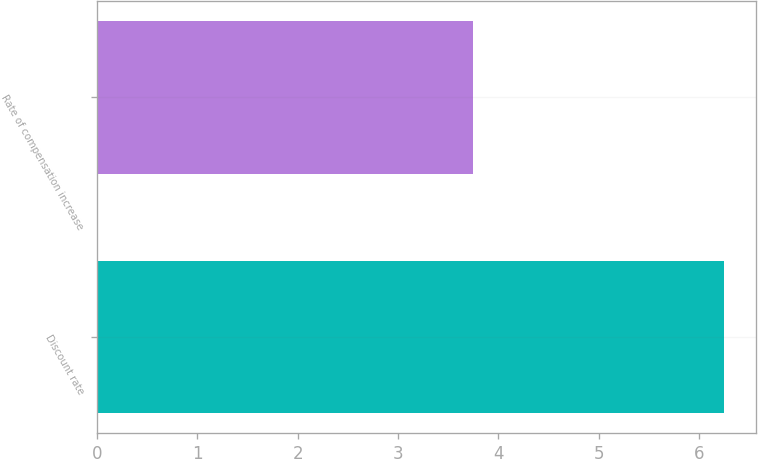<chart> <loc_0><loc_0><loc_500><loc_500><bar_chart><fcel>Discount rate<fcel>Rate of compensation increase<nl><fcel>6.25<fcel>3.75<nl></chart> 